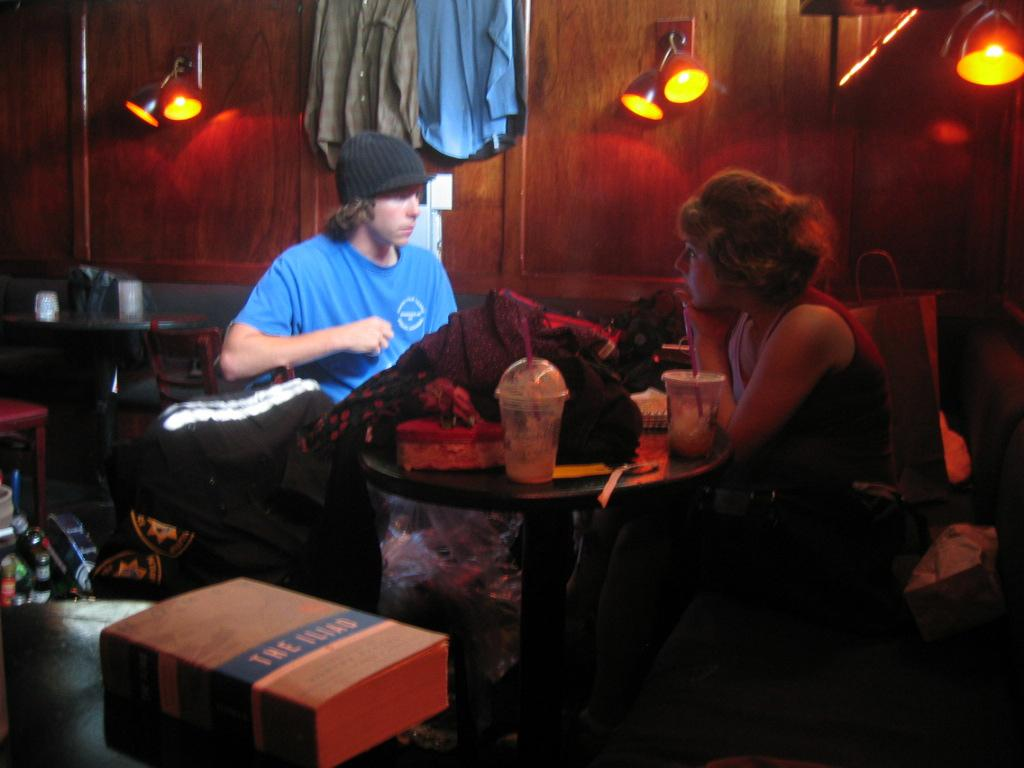What is the man in the image doing? The man is sitting in the image. What is the man wearing? The man is wearing a blue t-shirt. Who else is sitting in the image? There is a beautiful girl sitting in the image. What is the girl wearing? The girl is wearing a t-shirt. What can be seen on the table in the image? There are food items on the table in the image. What language is the man speaking in the image? The image does not provide any information about the language being spoken, as it only shows the man sitting and wearing a blue t-shirt. 